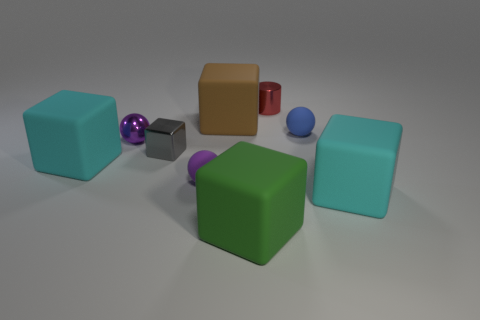Subtract all gray blocks. How many blocks are left? 4 Subtract 2 blocks. How many blocks are left? 3 Subtract all gray blocks. How many blocks are left? 4 Subtract all red cubes. Subtract all cyan cylinders. How many cubes are left? 5 Subtract all balls. How many objects are left? 6 Add 9 tiny red metallic objects. How many tiny red metallic objects exist? 10 Subtract 0 brown balls. How many objects are left? 9 Subtract all brown matte things. Subtract all big brown metallic spheres. How many objects are left? 8 Add 8 big cyan cubes. How many big cyan cubes are left? 10 